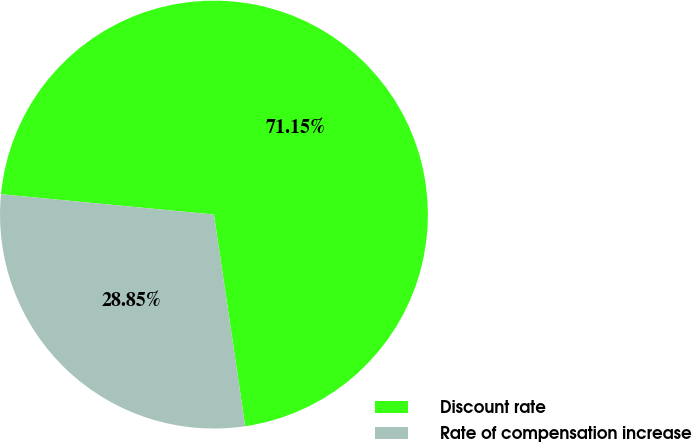<chart> <loc_0><loc_0><loc_500><loc_500><pie_chart><fcel>Discount rate<fcel>Rate of compensation increase<nl><fcel>71.15%<fcel>28.85%<nl></chart> 